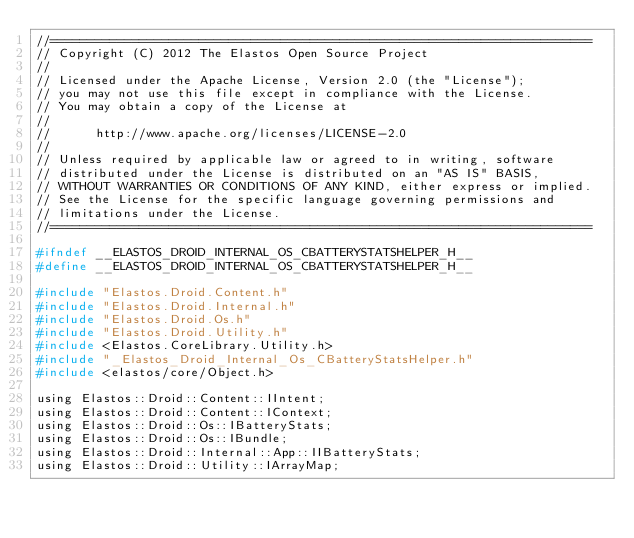Convert code to text. <code><loc_0><loc_0><loc_500><loc_500><_C_>//=========================================================================
// Copyright (C) 2012 The Elastos Open Source Project
//
// Licensed under the Apache License, Version 2.0 (the "License");
// you may not use this file except in compliance with the License.
// You may obtain a copy of the License at
//
//      http://www.apache.org/licenses/LICENSE-2.0
//
// Unless required by applicable law or agreed to in writing, software
// distributed under the License is distributed on an "AS IS" BASIS,
// WITHOUT WARRANTIES OR CONDITIONS OF ANY KIND, either express or implied.
// See the License for the specific language governing permissions and
// limitations under the License.
//=========================================================================

#ifndef __ELASTOS_DROID_INTERNAL_OS_CBATTERYSTATSHELPER_H__
#define __ELASTOS_DROID_INTERNAL_OS_CBATTERYSTATSHELPER_H__

#include "Elastos.Droid.Content.h"
#include "Elastos.Droid.Internal.h"
#include "Elastos.Droid.Os.h"
#include "Elastos.Droid.Utility.h"
#include <Elastos.CoreLibrary.Utility.h>
#include "_Elastos_Droid_Internal_Os_CBatteryStatsHelper.h"
#include <elastos/core/Object.h>

using Elastos::Droid::Content::IIntent;
using Elastos::Droid::Content::IContext;
using Elastos::Droid::Os::IBatteryStats;
using Elastos::Droid::Os::IBundle;
using Elastos::Droid::Internal::App::IIBatteryStats;
using Elastos::Droid::Utility::IArrayMap;</code> 